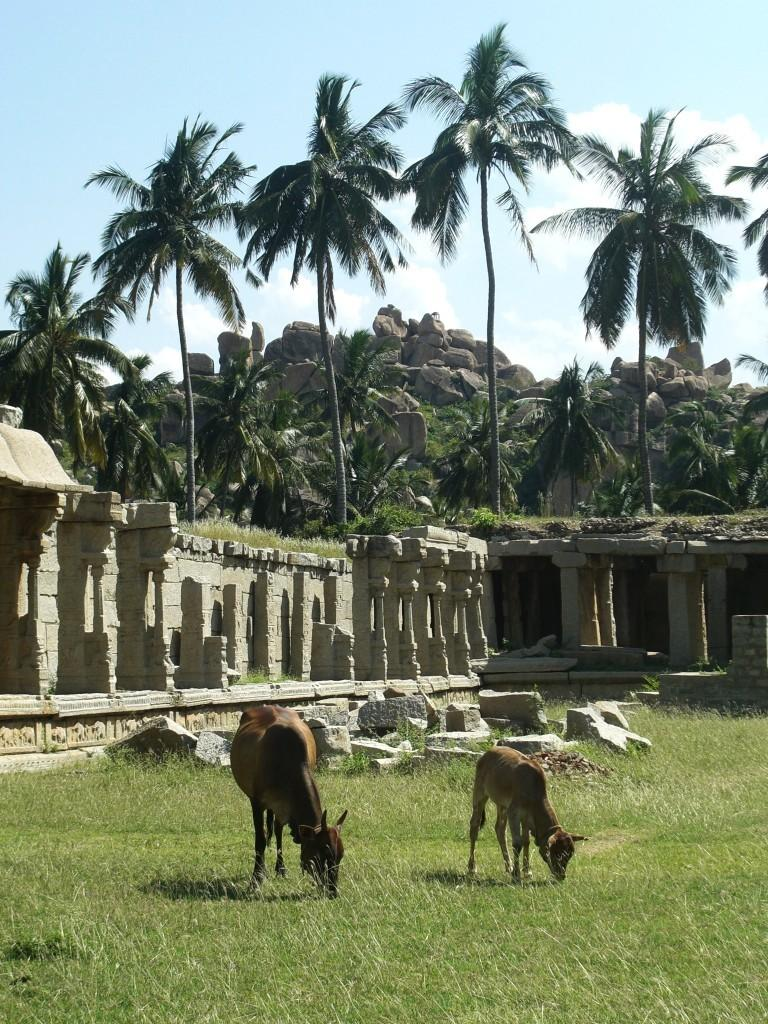How many cows are in the image? There are two cows in the image. What are the cows doing in the image? The cows are eating grass. What other objects or features can be seen in the image? There are stones, a monument, a mountain in the background, trees in the background, and the sky visible in the image. What is the weather like in the image? The sky appears cloudy in the image. What type of liquid is being sold by the business in the image? There is no business present in the image, so it is not possible to determine what type of liquid might be sold. 